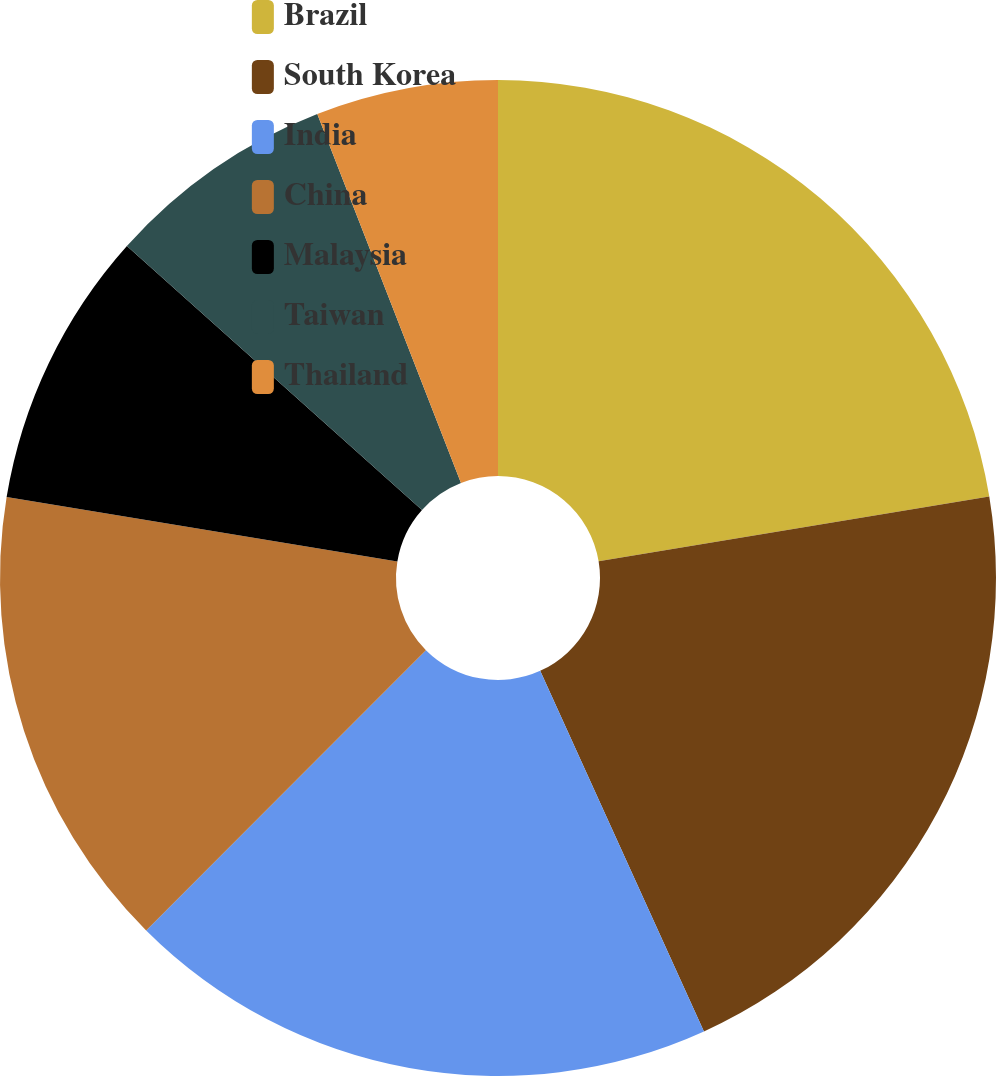Convert chart to OTSL. <chart><loc_0><loc_0><loc_500><loc_500><pie_chart><fcel>Brazil<fcel>South Korea<fcel>India<fcel>China<fcel>Malaysia<fcel>Taiwan<fcel>Thailand<nl><fcel>22.38%<fcel>20.83%<fcel>19.27%<fcel>15.11%<fcel>9.02%<fcel>7.47%<fcel>5.91%<nl></chart> 